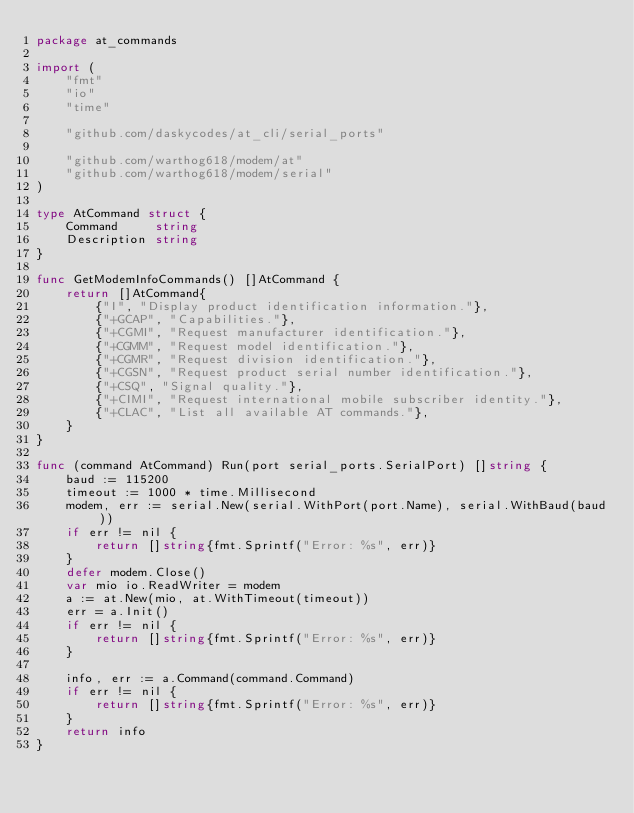<code> <loc_0><loc_0><loc_500><loc_500><_Go_>package at_commands

import (
	"fmt"
	"io"
	"time"

	"github.com/daskycodes/at_cli/serial_ports"

	"github.com/warthog618/modem/at"
	"github.com/warthog618/modem/serial"
)

type AtCommand struct {
	Command     string
	Description string
}

func GetModemInfoCommands() []AtCommand {
	return []AtCommand{
		{"I", "Display product identification information."},
		{"+GCAP", "Capabilities."},
		{"+CGMI", "Request manufacturer identification."},
		{"+CGMM", "Request model identification."},
		{"+CGMR", "Request division identification."},
		{"+CGSN", "Request product serial number identification."},
		{"+CSQ", "Signal quality."},
		{"+CIMI", "Request international mobile subscriber identity."},
		{"+CLAC", "List all available AT commands."},
	}
}

func (command AtCommand) Run(port serial_ports.SerialPort) []string {
	baud := 115200
	timeout := 1000 * time.Millisecond
	modem, err := serial.New(serial.WithPort(port.Name), serial.WithBaud(baud))
	if err != nil {
		return []string{fmt.Sprintf("Error: %s", err)}
	}
	defer modem.Close()
	var mio io.ReadWriter = modem
	a := at.New(mio, at.WithTimeout(timeout))
	err = a.Init()
	if err != nil {
		return []string{fmt.Sprintf("Error: %s", err)}
	}

	info, err := a.Command(command.Command)
	if err != nil {
		return []string{fmt.Sprintf("Error: %s", err)}
	}
	return info
}
</code> 